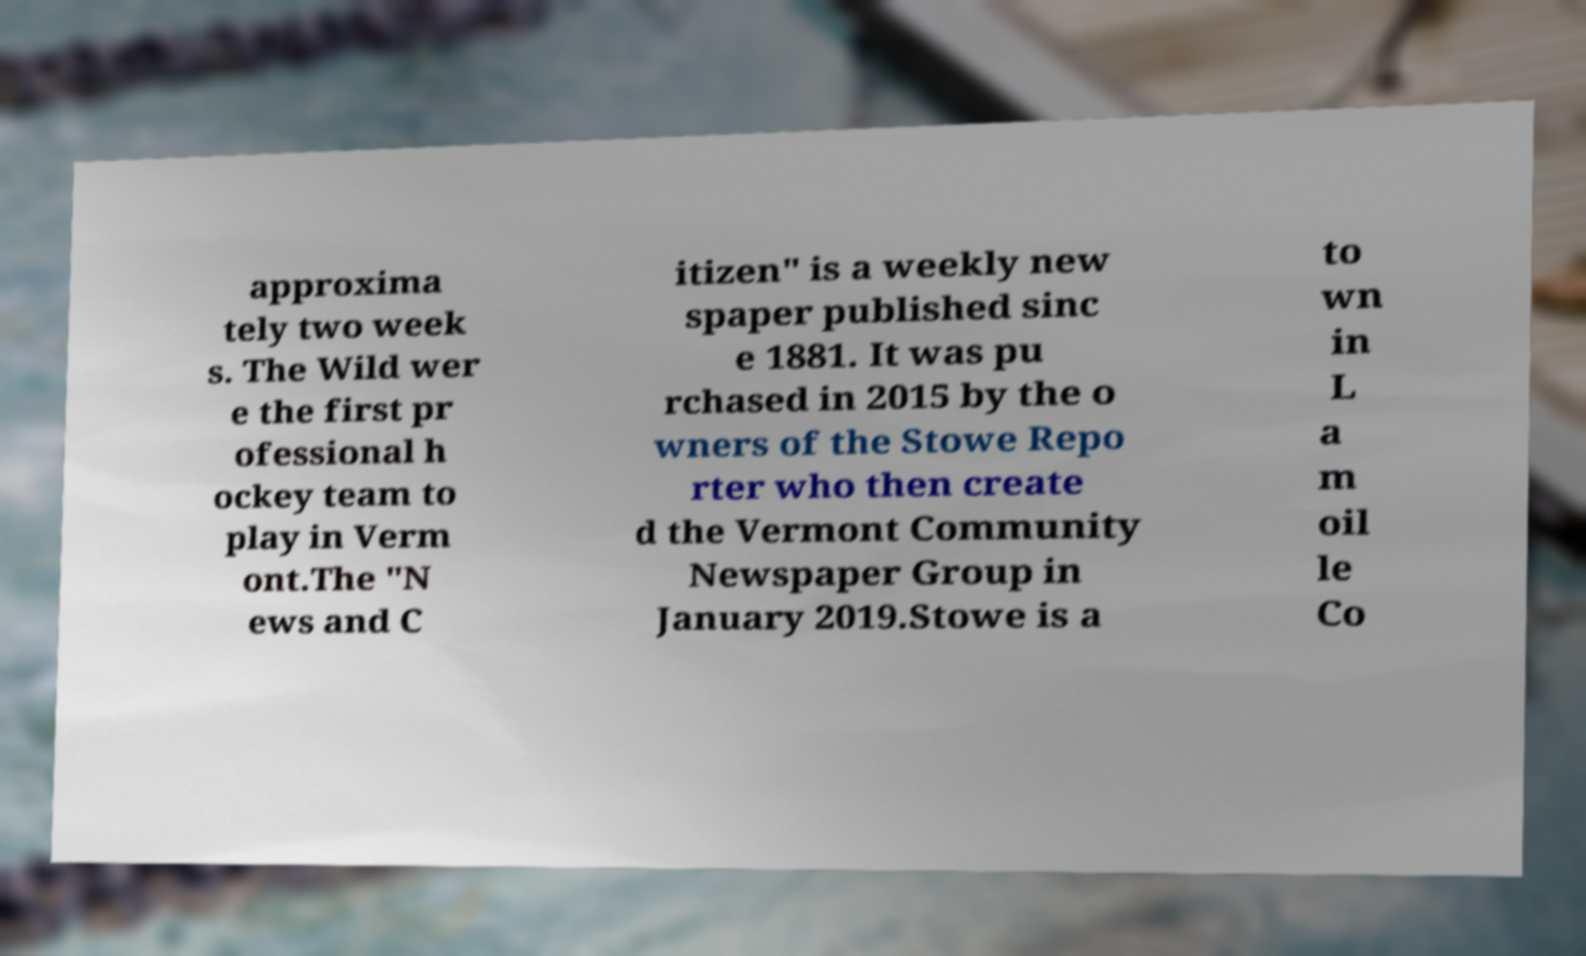For documentation purposes, I need the text within this image transcribed. Could you provide that? approxima tely two week s. The Wild wer e the first pr ofessional h ockey team to play in Verm ont.The "N ews and C itizen" is a weekly new spaper published sinc e 1881. It was pu rchased in 2015 by the o wners of the Stowe Repo rter who then create d the Vermont Community Newspaper Group in January 2019.Stowe is a to wn in L a m oil le Co 